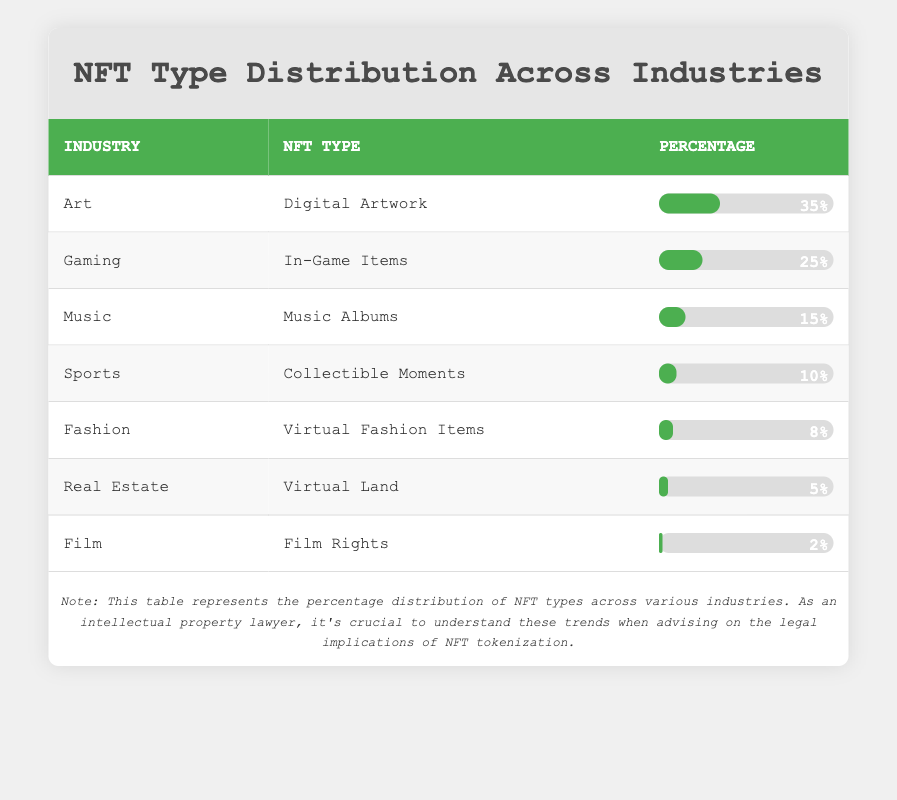What is the NFT type with the highest percentage distribution? From the table, the NFT type with the highest percentage distribution is "Digital Artwork" in the Art industry, which has a percentage of 35%.
Answer: Digital Artwork How much percentage does the Fashion industry represent in NFT types? The Fashion industry represents a percentage of 8% for "Virtual Fashion Items" according to the table.
Answer: 8% Is the percentage of Music NFT types higher than that of Sports NFT types? The Music industry has a percentage of 15% for "Music Albums," while the Sports industry has a percentage of 10% for "Collectible Moments." Since 15% is greater than 10%, the answer is yes.
Answer: Yes What percentage of NFT types does Real Estate and Film together represent? The percentage for Real Estate is 5% for "Virtual Land" and for Film, it is 2% for "Film Rights." Adding them together gives us 5% + 2% = 7%.
Answer: 7% Which industry has the least percentage distribution for NFT types? The table shows that the Film industry has the least percentage distribution with only 2% for "Film Rights."
Answer: Film What is the percentage difference between Art and Gaming NFT types? The percentage for Art is 35% and for Gaming, it is 25%. The difference is 35% - 25% = 10%.
Answer: 10% If we consider only the top three industries by percentage, what is their combined percentage? The top three industries are Art (35%), Gaming (25%), and Music (15%). Their combined percentage is 35% + 25% + 15% = 75%.
Answer: 75% Does the total percentage of Sports and Fashion NFTs exceed that of Music NFTs? Sports has 10% and Fashion has 8%, which totals 10% + 8% = 18%. Music has 15%. Since 18% is greater than 15%, the answer is yes.
Answer: Yes What industry has the second highest percentage after Art? After Art, Gaming with 25% for "In-Game Items" is the second highest industry percentage listed in the table.
Answer: Gaming 